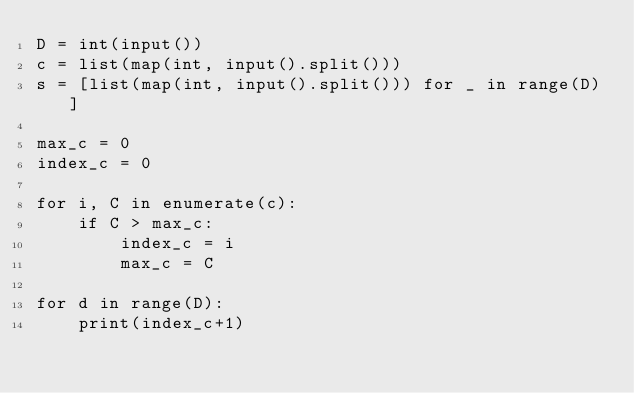<code> <loc_0><loc_0><loc_500><loc_500><_Python_>D = int(input())
c = list(map(int, input().split()))
s = [list(map(int, input().split())) for _ in range(D)]

max_c = 0
index_c = 0

for i, C in enumerate(c):
    if C > max_c:
        index_c = i
        max_c = C

for d in range(D):
    print(index_c+1)
</code> 